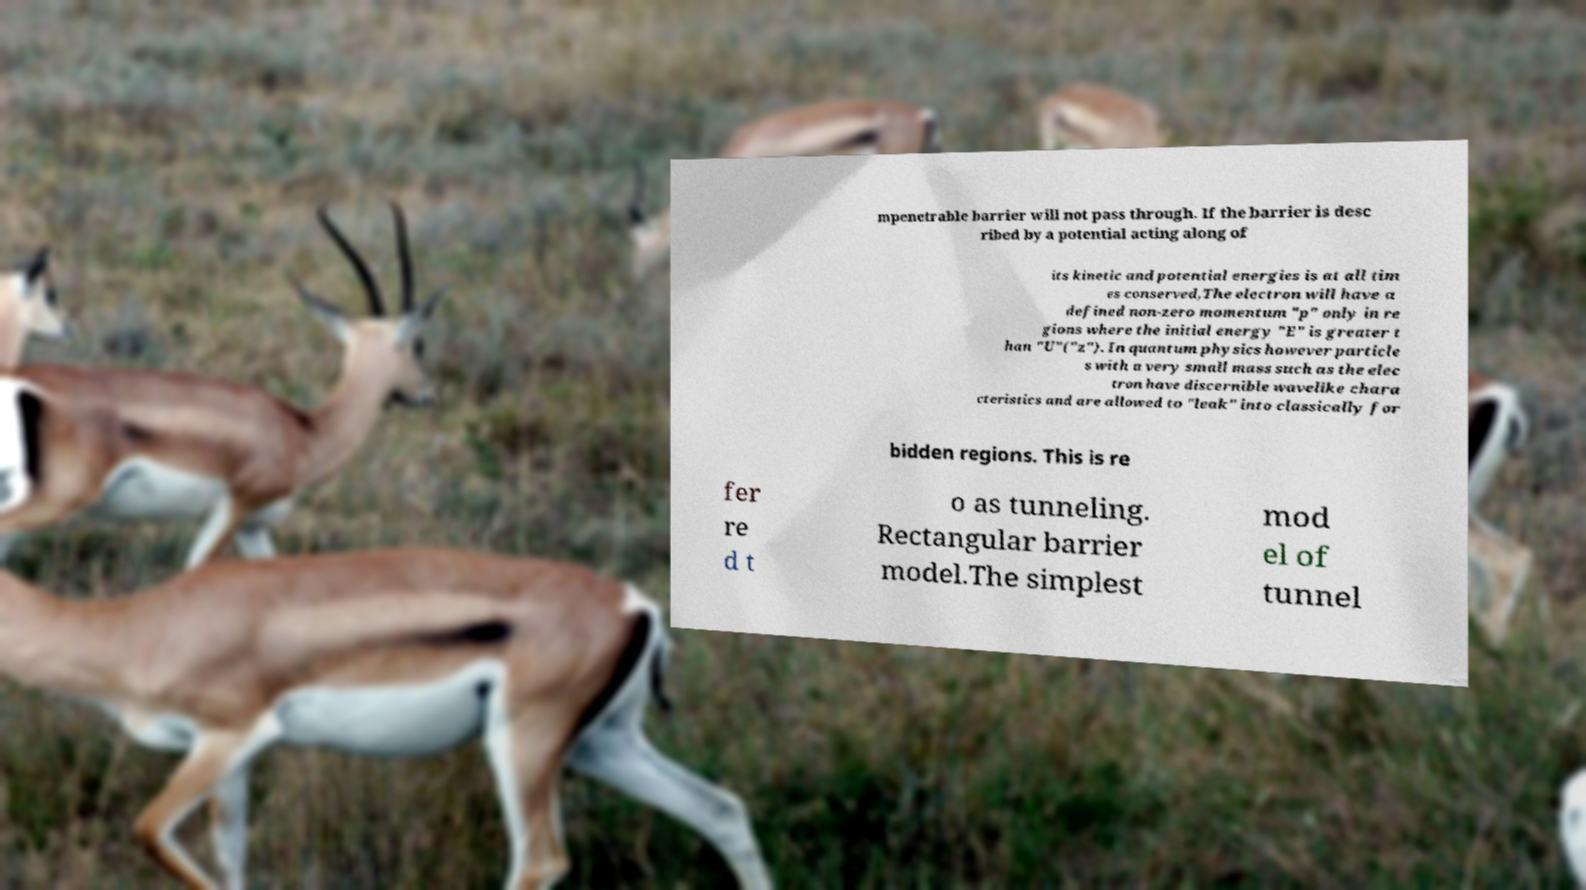There's text embedded in this image that I need extracted. Can you transcribe it verbatim? mpenetrable barrier will not pass through. If the barrier is desc ribed by a potential acting along of its kinetic and potential energies is at all tim es conserved,The electron will have a defined non-zero momentum "p" only in re gions where the initial energy "E" is greater t han "U"("z"). In quantum physics however particle s with a very small mass such as the elec tron have discernible wavelike chara cteristics and are allowed to "leak" into classically for bidden regions. This is re fer re d t o as tunneling. Rectangular barrier model.The simplest mod el of tunnel 